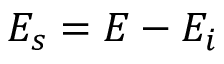<formula> <loc_0><loc_0><loc_500><loc_500>E _ { s } = E - E _ { i }</formula> 